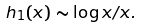<formula> <loc_0><loc_0><loc_500><loc_500>h _ { 1 } ( x ) \sim \log { x } / x .</formula> 